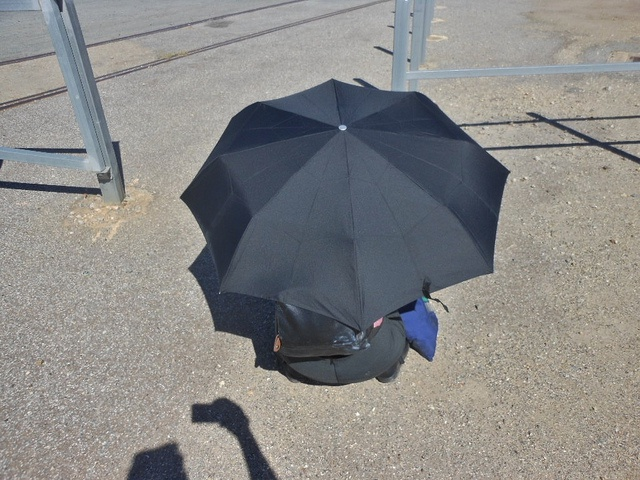Describe the objects in this image and their specific colors. I can see umbrella in gray, black, and darkblue tones, handbag in gray and black tones, and handbag in gray, blue, darkblue, and black tones in this image. 